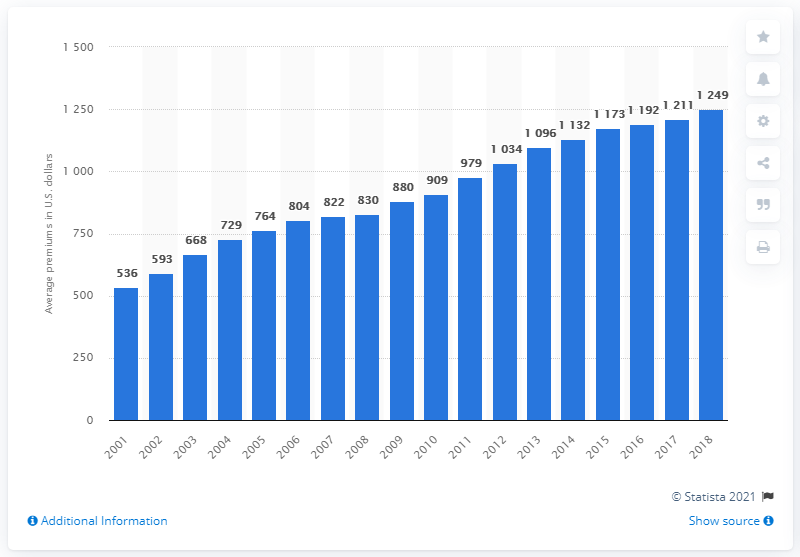Point out several critical features in this image. The average premium for homeowners insurance in 2005 was 764. 